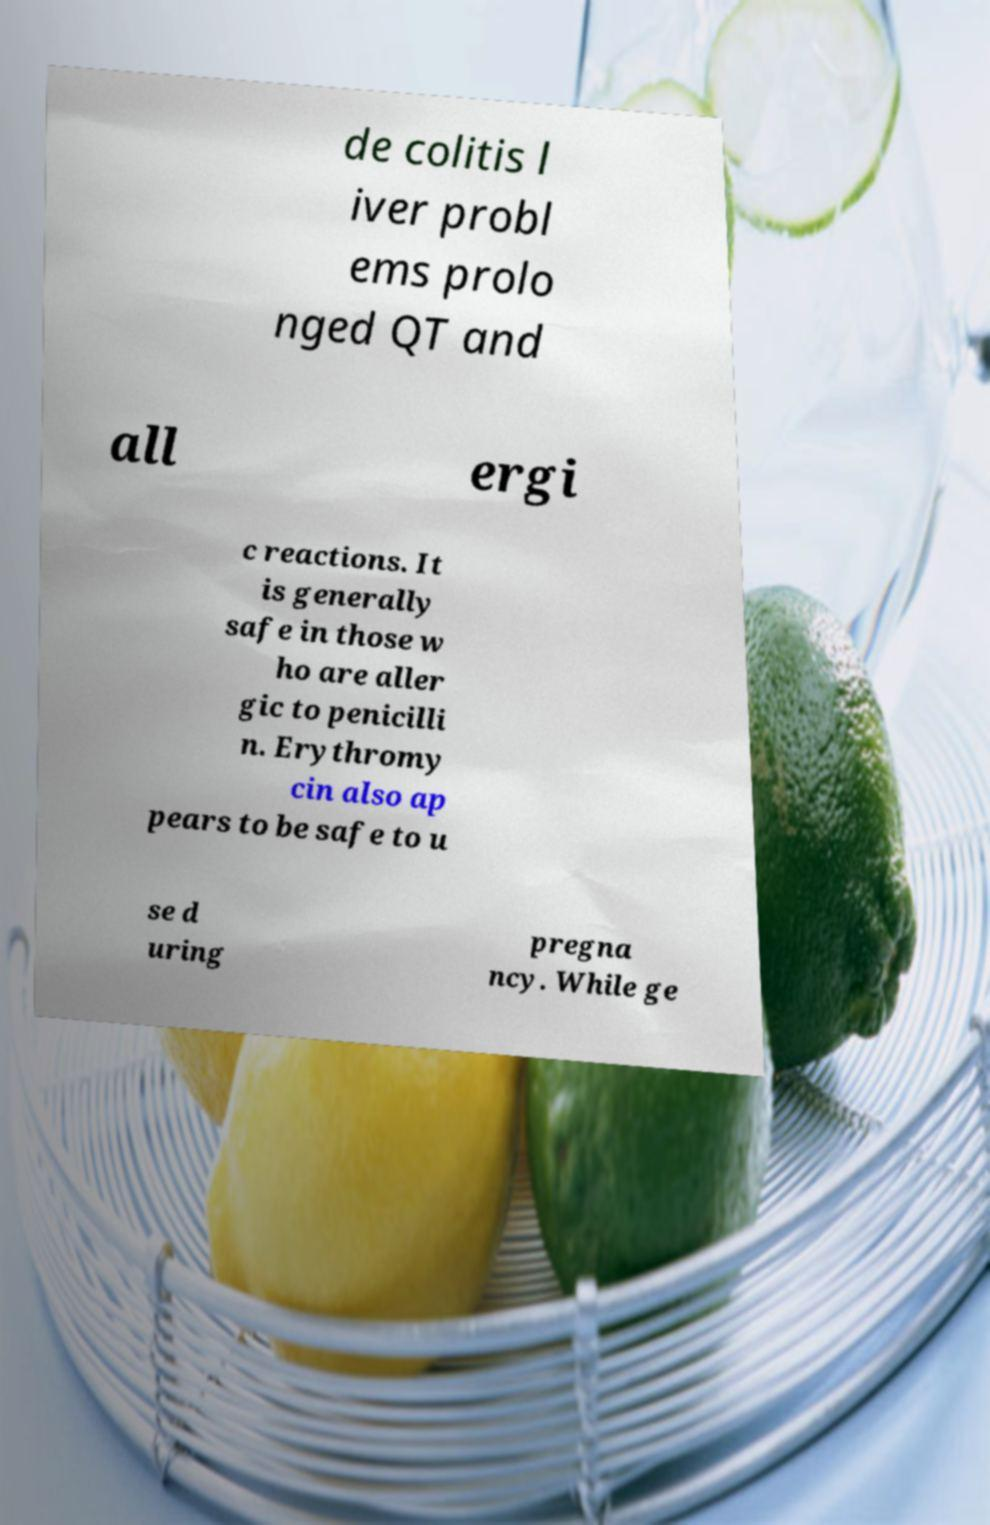For documentation purposes, I need the text within this image transcribed. Could you provide that? de colitis l iver probl ems prolo nged QT and all ergi c reactions. It is generally safe in those w ho are aller gic to penicilli n. Erythromy cin also ap pears to be safe to u se d uring pregna ncy. While ge 